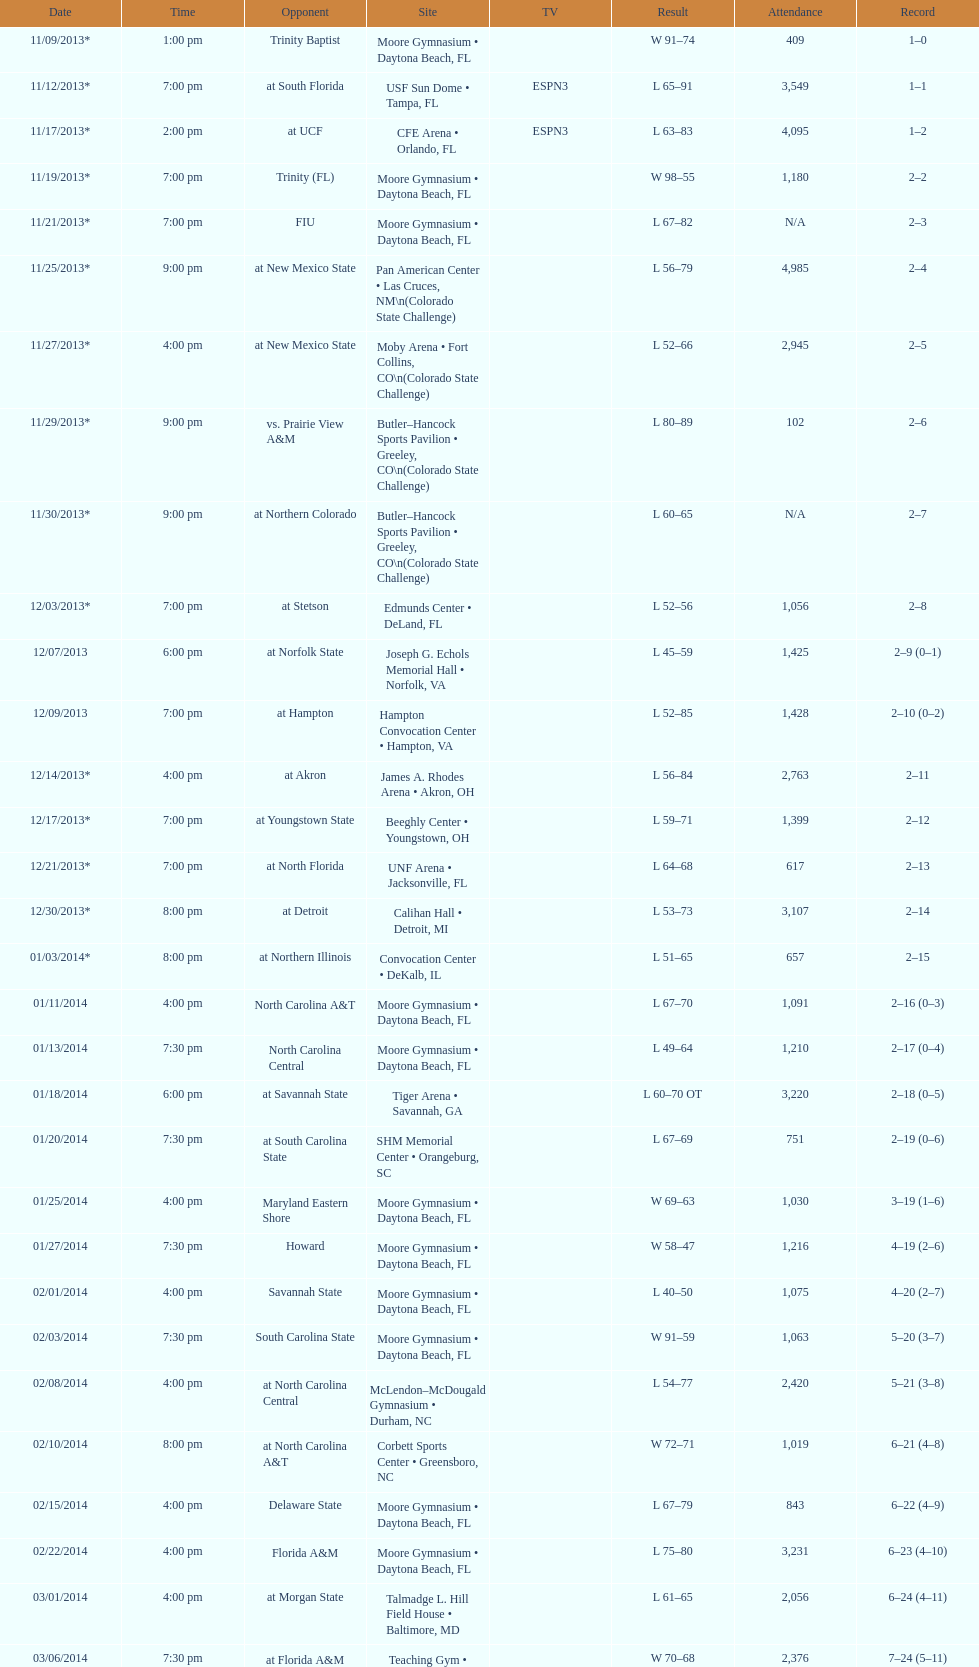Which game took place later in the evening, fiu or northern colorado? Northern Colorado. 